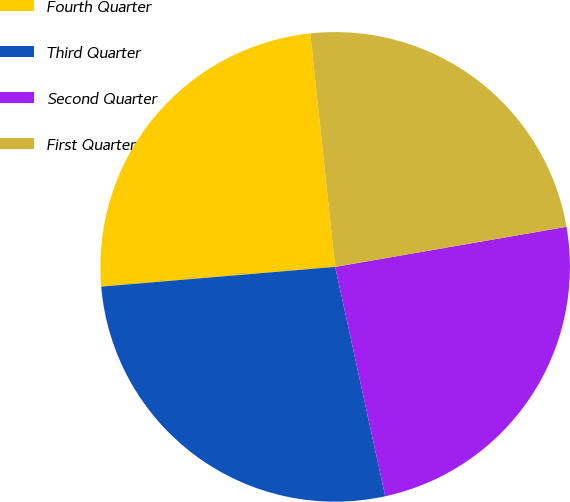<chart> <loc_0><loc_0><loc_500><loc_500><pie_chart><fcel>Fourth Quarter<fcel>Third Quarter<fcel>Second Quarter<fcel>First Quarter<nl><fcel>24.65%<fcel>27.08%<fcel>24.31%<fcel>23.96%<nl></chart> 